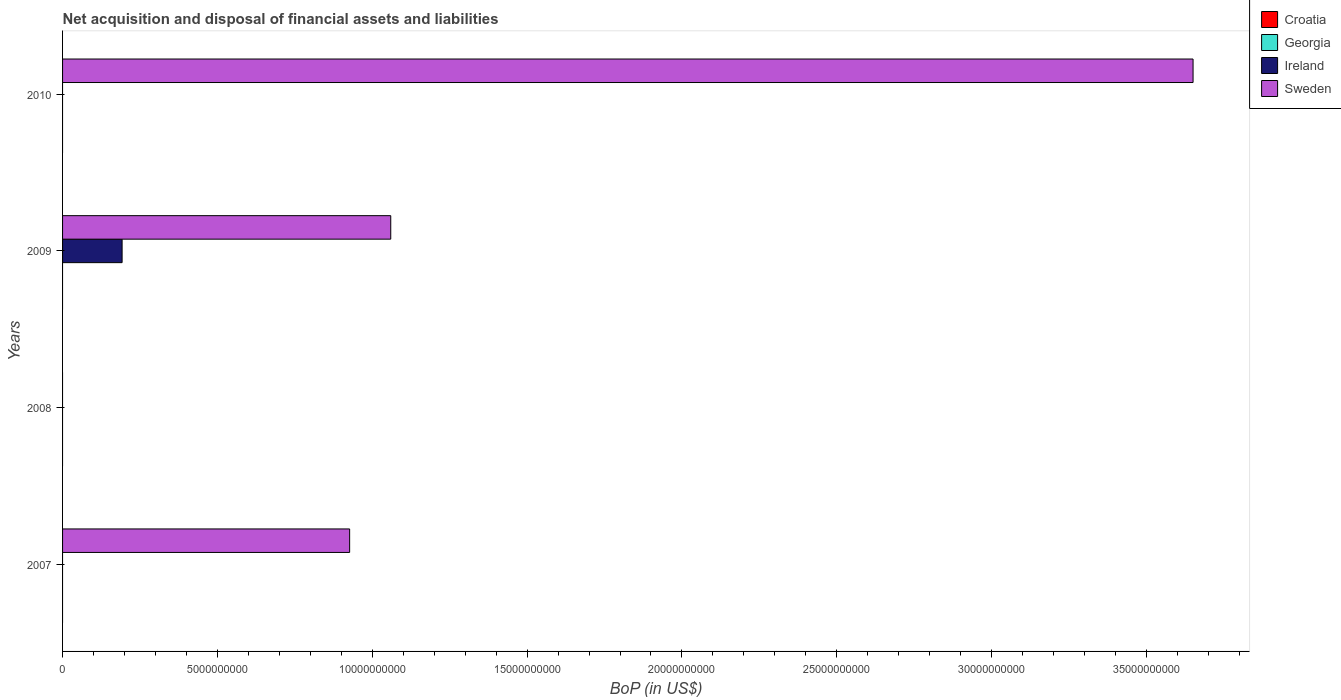Are the number of bars per tick equal to the number of legend labels?
Provide a short and direct response. No. Are the number of bars on each tick of the Y-axis equal?
Your answer should be compact. No. How many bars are there on the 4th tick from the bottom?
Ensure brevity in your answer.  1. Across all years, what is the maximum Balance of Payments in Ireland?
Ensure brevity in your answer.  1.92e+09. In which year was the Balance of Payments in Sweden maximum?
Keep it short and to the point. 2010. What is the total Balance of Payments in Ireland in the graph?
Offer a terse response. 1.92e+09. What is the difference between the Balance of Payments in Sweden in 2007 and that in 2009?
Keep it short and to the point. -1.33e+09. In how many years, is the Balance of Payments in Georgia greater than 20000000000 US$?
Offer a very short reply. 0. What is the ratio of the Balance of Payments in Sweden in 2007 to that in 2009?
Offer a very short reply. 0.87. What is the difference between the highest and the second highest Balance of Payments in Sweden?
Provide a short and direct response. 2.59e+1. What is the difference between the highest and the lowest Balance of Payments in Ireland?
Offer a very short reply. 1.92e+09. Is the sum of the Balance of Payments in Sweden in 2007 and 2010 greater than the maximum Balance of Payments in Georgia across all years?
Your answer should be very brief. Yes. Is it the case that in every year, the sum of the Balance of Payments in Ireland and Balance of Payments in Sweden is greater than the sum of Balance of Payments in Croatia and Balance of Payments in Georgia?
Make the answer very short. No. How many bars are there?
Your answer should be very brief. 4. Are all the bars in the graph horizontal?
Offer a very short reply. Yes. How many years are there in the graph?
Give a very brief answer. 4. Does the graph contain any zero values?
Your response must be concise. Yes. How are the legend labels stacked?
Make the answer very short. Vertical. What is the title of the graph?
Offer a terse response. Net acquisition and disposal of financial assets and liabilities. What is the label or title of the X-axis?
Offer a very short reply. BoP (in US$). What is the BoP (in US$) in Georgia in 2007?
Ensure brevity in your answer.  0. What is the BoP (in US$) in Ireland in 2007?
Give a very brief answer. 0. What is the BoP (in US$) in Sweden in 2007?
Your response must be concise. 9.27e+09. What is the BoP (in US$) in Croatia in 2008?
Give a very brief answer. 0. What is the BoP (in US$) in Ireland in 2008?
Make the answer very short. 0. What is the BoP (in US$) of Sweden in 2008?
Offer a terse response. 0. What is the BoP (in US$) of Ireland in 2009?
Your answer should be very brief. 1.92e+09. What is the BoP (in US$) of Sweden in 2009?
Ensure brevity in your answer.  1.06e+1. What is the BoP (in US$) of Ireland in 2010?
Your answer should be very brief. 0. What is the BoP (in US$) in Sweden in 2010?
Your answer should be compact. 3.65e+1. Across all years, what is the maximum BoP (in US$) in Ireland?
Your answer should be very brief. 1.92e+09. Across all years, what is the maximum BoP (in US$) in Sweden?
Offer a terse response. 3.65e+1. Across all years, what is the minimum BoP (in US$) of Sweden?
Offer a very short reply. 0. What is the total BoP (in US$) in Croatia in the graph?
Offer a terse response. 0. What is the total BoP (in US$) of Ireland in the graph?
Offer a very short reply. 1.92e+09. What is the total BoP (in US$) of Sweden in the graph?
Ensure brevity in your answer.  5.64e+1. What is the difference between the BoP (in US$) in Sweden in 2007 and that in 2009?
Give a very brief answer. -1.33e+09. What is the difference between the BoP (in US$) of Sweden in 2007 and that in 2010?
Give a very brief answer. -2.72e+1. What is the difference between the BoP (in US$) in Sweden in 2009 and that in 2010?
Provide a short and direct response. -2.59e+1. What is the difference between the BoP (in US$) in Ireland in 2009 and the BoP (in US$) in Sweden in 2010?
Give a very brief answer. -3.46e+1. What is the average BoP (in US$) of Ireland per year?
Keep it short and to the point. 4.81e+08. What is the average BoP (in US$) in Sweden per year?
Your answer should be very brief. 1.41e+1. In the year 2009, what is the difference between the BoP (in US$) in Ireland and BoP (in US$) in Sweden?
Offer a terse response. -8.68e+09. What is the ratio of the BoP (in US$) in Sweden in 2007 to that in 2009?
Offer a terse response. 0.87. What is the ratio of the BoP (in US$) in Sweden in 2007 to that in 2010?
Make the answer very short. 0.25. What is the ratio of the BoP (in US$) of Sweden in 2009 to that in 2010?
Make the answer very short. 0.29. What is the difference between the highest and the second highest BoP (in US$) of Sweden?
Offer a terse response. 2.59e+1. What is the difference between the highest and the lowest BoP (in US$) of Ireland?
Offer a terse response. 1.92e+09. What is the difference between the highest and the lowest BoP (in US$) of Sweden?
Your answer should be very brief. 3.65e+1. 